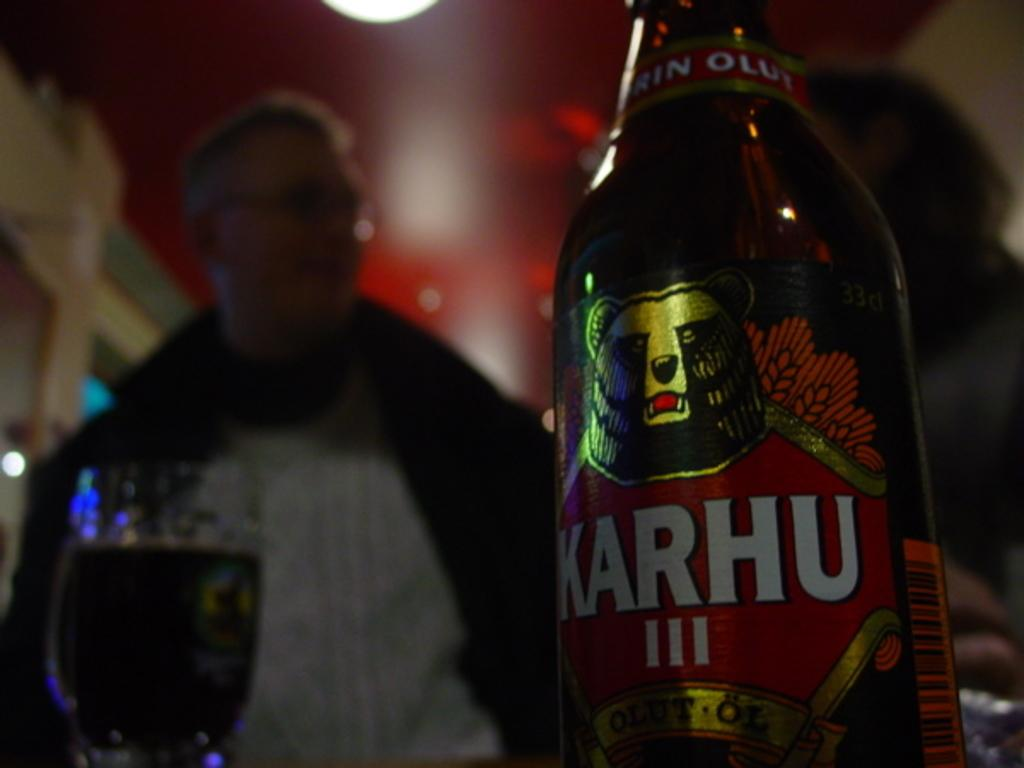<image>
Provide a brief description of the given image. In a dark room a bottle of Karhu III is in front of a man. 